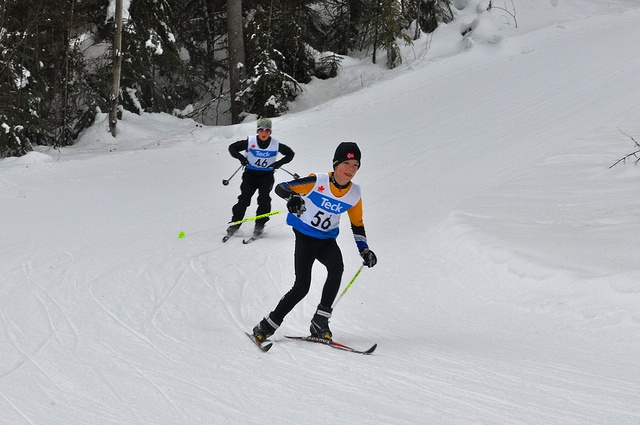Describe the objects in this image and their specific colors. I can see people in black, darkgray, and lightgray tones, people in black, darkgray, and gray tones, skis in black, gray, darkgray, and lightgray tones, and skis in black, gray, darkgray, and lightgray tones in this image. 